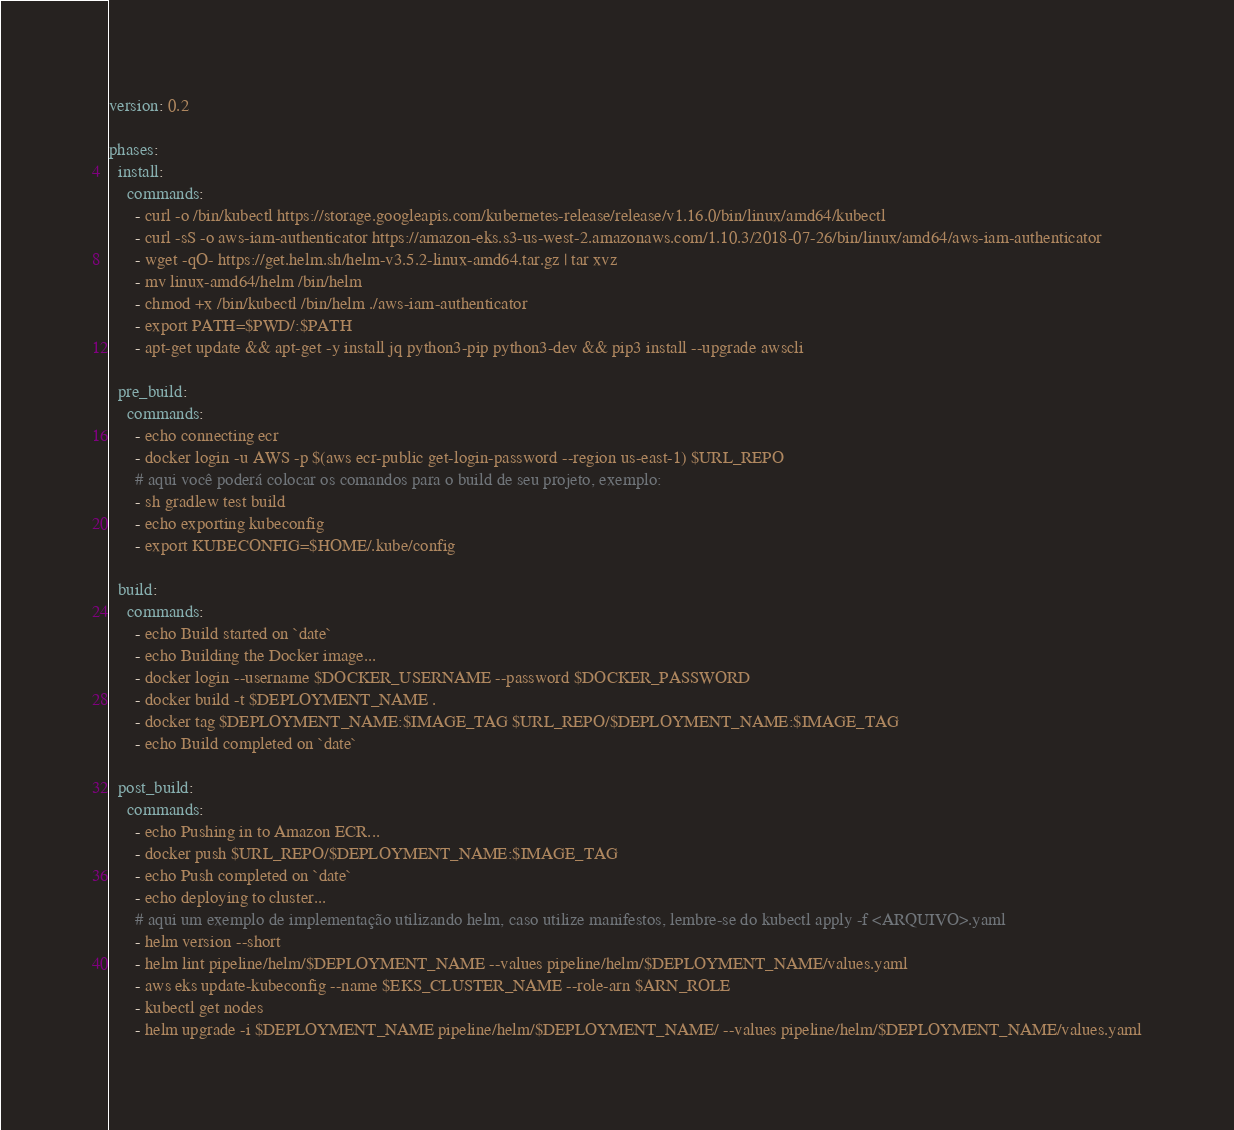Convert code to text. <code><loc_0><loc_0><loc_500><loc_500><_YAML_>version: 0.2

phases:
  install:
    commands:
      - curl -o /bin/kubectl https://storage.googleapis.com/kubernetes-release/release/v1.16.0/bin/linux/amd64/kubectl
      - curl -sS -o aws-iam-authenticator https://amazon-eks.s3-us-west-2.amazonaws.com/1.10.3/2018-07-26/bin/linux/amd64/aws-iam-authenticator
      - wget -qO- https://get.helm.sh/helm-v3.5.2-linux-amd64.tar.gz | tar xvz
      - mv linux-amd64/helm /bin/helm
      - chmod +x /bin/kubectl /bin/helm ./aws-iam-authenticator
      - export PATH=$PWD/:$PATH
      - apt-get update && apt-get -y install jq python3-pip python3-dev && pip3 install --upgrade awscli

  pre_build:
    commands:
      - echo connecting ecr
      - docker login -u AWS -p $(aws ecr-public get-login-password --region us-east-1) $URL_REPO
      # aqui você poderá colocar os comandos para o build de seu projeto, exemplo:
      - sh gradlew test build
      - echo exporting kubeconfig
      - export KUBECONFIG=$HOME/.kube/config

  build:
    commands:
      - echo Build started on `date`
      - echo Building the Docker image...
      - docker login --username $DOCKER_USERNAME --password $DOCKER_PASSWORD
      - docker build -t $DEPLOYMENT_NAME .
      - docker tag $DEPLOYMENT_NAME:$IMAGE_TAG $URL_REPO/$DEPLOYMENT_NAME:$IMAGE_TAG
      - echo Build completed on `date`

  post_build:
    commands:
      - echo Pushing in to Amazon ECR...
      - docker push $URL_REPO/$DEPLOYMENT_NAME:$IMAGE_TAG
      - echo Push completed on `date`
      - echo deploying to cluster...
      # aqui um exemplo de implementação utilizando helm, caso utilize manifestos, lembre-se do kubectl apply -f <ARQUIVO>.yaml
      - helm version --short
      - helm lint pipeline/helm/$DEPLOYMENT_NAME --values pipeline/helm/$DEPLOYMENT_NAME/values.yaml
      - aws eks update-kubeconfig --name $EKS_CLUSTER_NAME --role-arn $ARN_ROLE
      - kubectl get nodes
      - helm upgrade -i $DEPLOYMENT_NAME pipeline/helm/$DEPLOYMENT_NAME/ --values pipeline/helm/$DEPLOYMENT_NAME/values.yaml</code> 